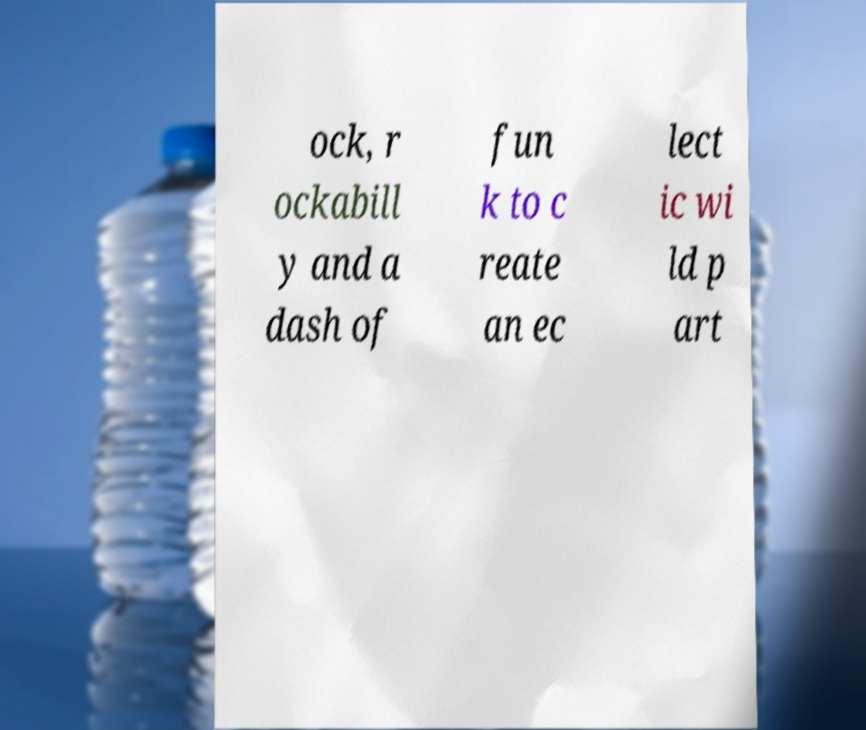For documentation purposes, I need the text within this image transcribed. Could you provide that? ock, r ockabill y and a dash of fun k to c reate an ec lect ic wi ld p art 